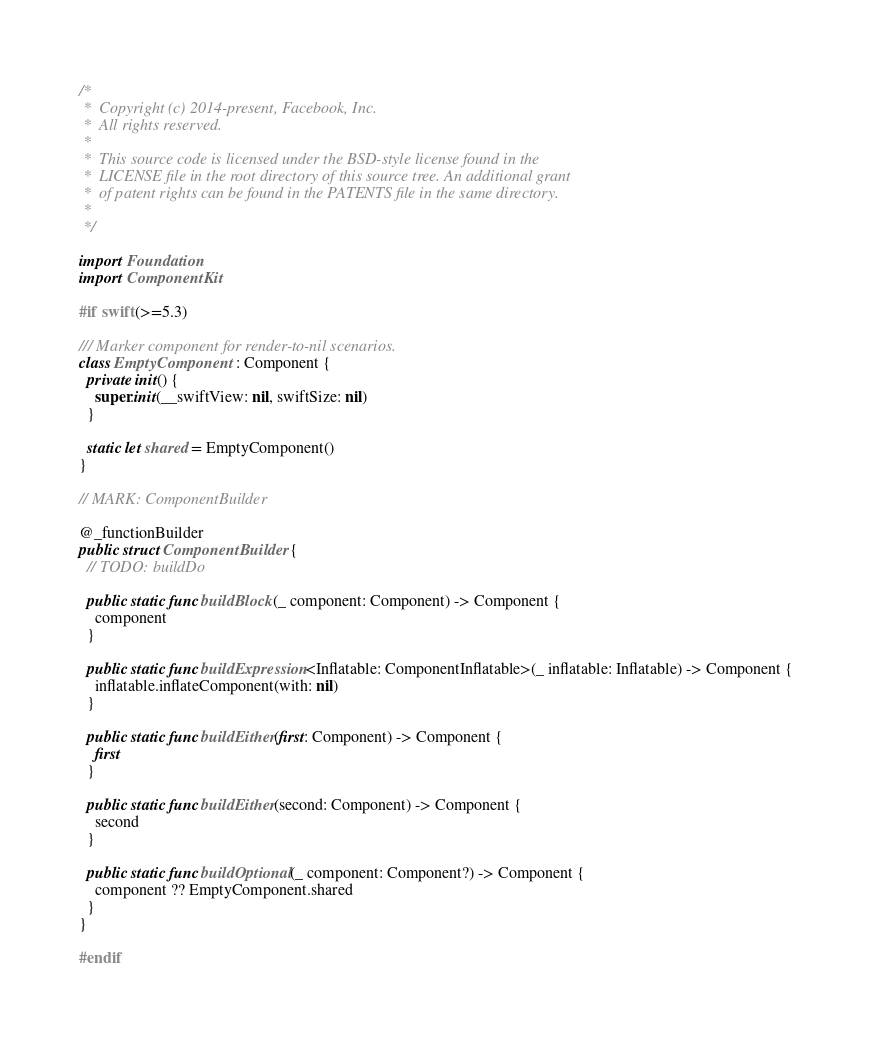<code> <loc_0><loc_0><loc_500><loc_500><_Swift_>/*
 *  Copyright (c) 2014-present, Facebook, Inc.
 *  All rights reserved.
 *
 *  This source code is licensed under the BSD-style license found in the
 *  LICENSE file in the root directory of this source tree. An additional grant
 *  of patent rights can be found in the PATENTS file in the same directory.
 *
 */

import Foundation
import ComponentKit

#if swift(>=5.3)

/// Marker component for render-to-nil scenarios.
class EmptyComponent : Component {
  private init() {
    super.init(__swiftView: nil, swiftSize: nil)
  }

  static let shared = EmptyComponent()
}

// MARK: ComponentBuilder

@_functionBuilder
public struct ComponentBuilder {
  // TODO: buildDo

  public static func buildBlock(_ component: Component) -> Component {
    component
  }

  public static func buildExpression<Inflatable: ComponentInflatable>(_ inflatable: Inflatable) -> Component {
    inflatable.inflateComponent(with: nil)
  }

  public static func buildEither(first: Component) -> Component {
    first
  }

  public static func buildEither(second: Component) -> Component {
    second
  }

  public static func buildOptional(_ component: Component?) -> Component {
    component ?? EmptyComponent.shared
  }
}

#endif
</code> 